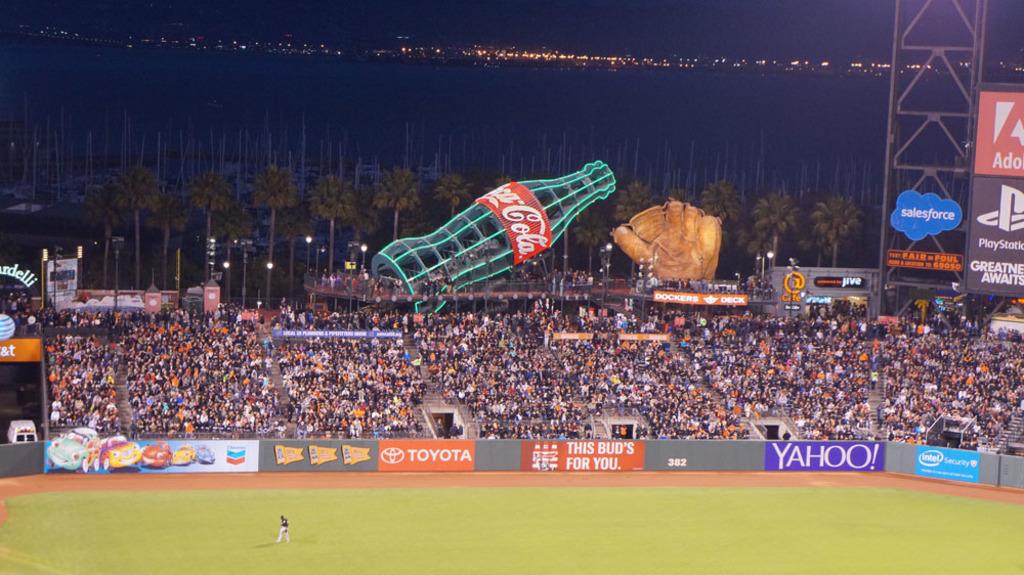Is there a coca cola bottle shown?
Keep it short and to the point. Yes. 